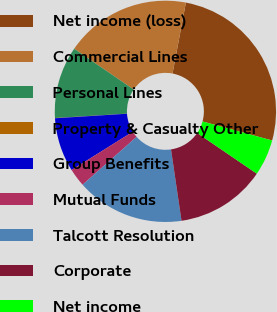Convert chart to OTSL. <chart><loc_0><loc_0><loc_500><loc_500><pie_chart><fcel>Net income (loss)<fcel>Commercial Lines<fcel>Personal Lines<fcel>Property & Casualty Other<fcel>Group Benefits<fcel>Mutual Funds<fcel>Talcott Resolution<fcel>Corporate<fcel>Net income<nl><fcel>26.28%<fcel>18.4%<fcel>10.53%<fcel>0.03%<fcel>7.9%<fcel>2.65%<fcel>15.78%<fcel>13.15%<fcel>5.28%<nl></chart> 